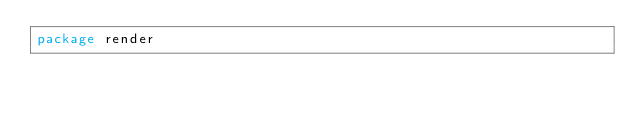Convert code to text. <code><loc_0><loc_0><loc_500><loc_500><_Go_>package render</code> 